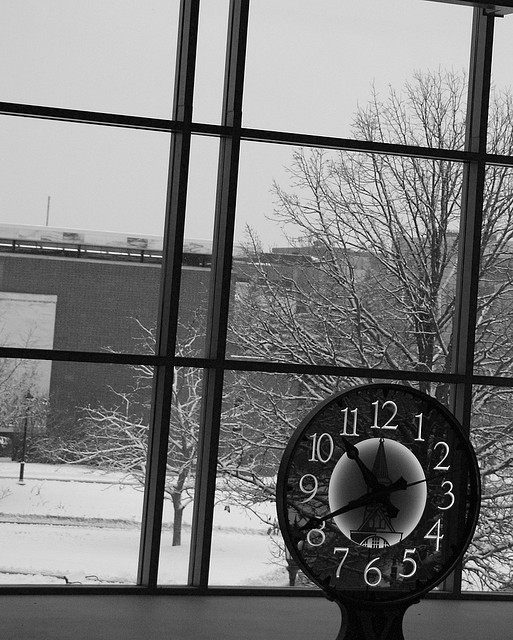Read and extract the text from this image. 12 1 2 3 4 5 6 7 8 9 10 11 